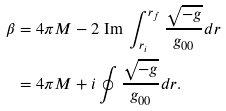<formula> <loc_0><loc_0><loc_500><loc_500>\beta & = 4 \pi M - 2 \text { Im } \int _ { r _ { i } } ^ { r _ { f } } \frac { \sqrt { - g } } { g _ { 0 0 } } d r \\ & = 4 \pi M + i \oint \frac { \sqrt { - g } } { g _ { 0 0 } } d r .</formula> 